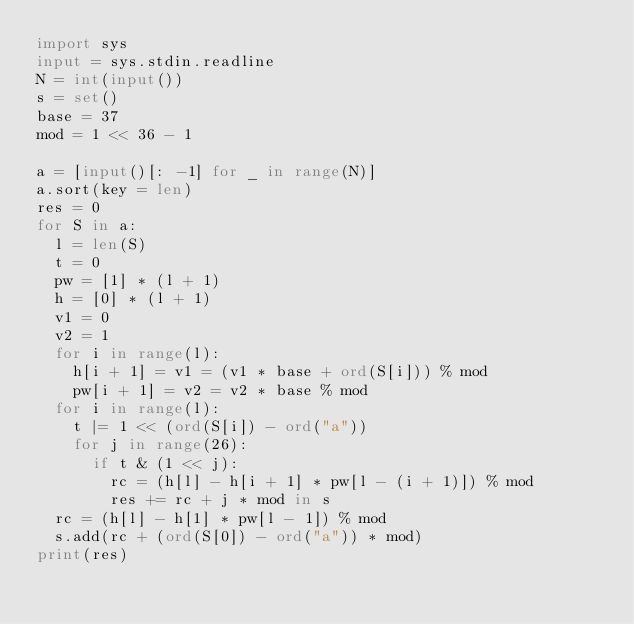Convert code to text. <code><loc_0><loc_0><loc_500><loc_500><_Python_>import sys
input = sys.stdin.readline
N = int(input())
s = set()
base = 37
mod = 1 << 36 - 1

a = [input()[: -1] for _ in range(N)]
a.sort(key = len)
res = 0
for S in a:
  l = len(S)
  t = 0
  pw = [1] * (l + 1)
  h = [0] * (l + 1)
  v1 = 0
  v2 = 1
  for i in range(l):
    h[i + 1] = v1 = (v1 * base + ord(S[i])) % mod
    pw[i + 1] = v2 = v2 * base % mod
  for i in range(l):
    t |= 1 << (ord(S[i]) - ord("a"))
    for j in range(26):
      if t & (1 << j):
        rc = (h[l] - h[i + 1] * pw[l - (i + 1)]) % mod
        res += rc + j * mod in s
  rc = (h[l] - h[1] * pw[l - 1]) % mod
  s.add(rc + (ord(S[0]) - ord("a")) * mod)
print(res)</code> 